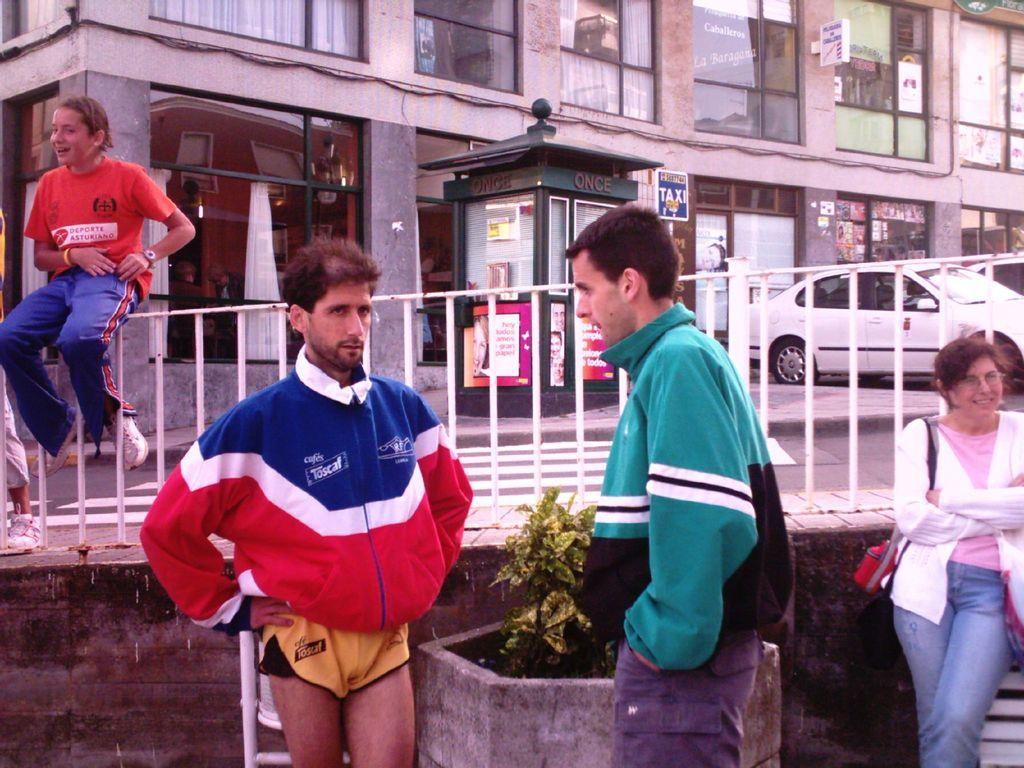<image>
Write a terse but informative summary of the picture. A guy in a red white and blue jacket that says Toscaf on it. 